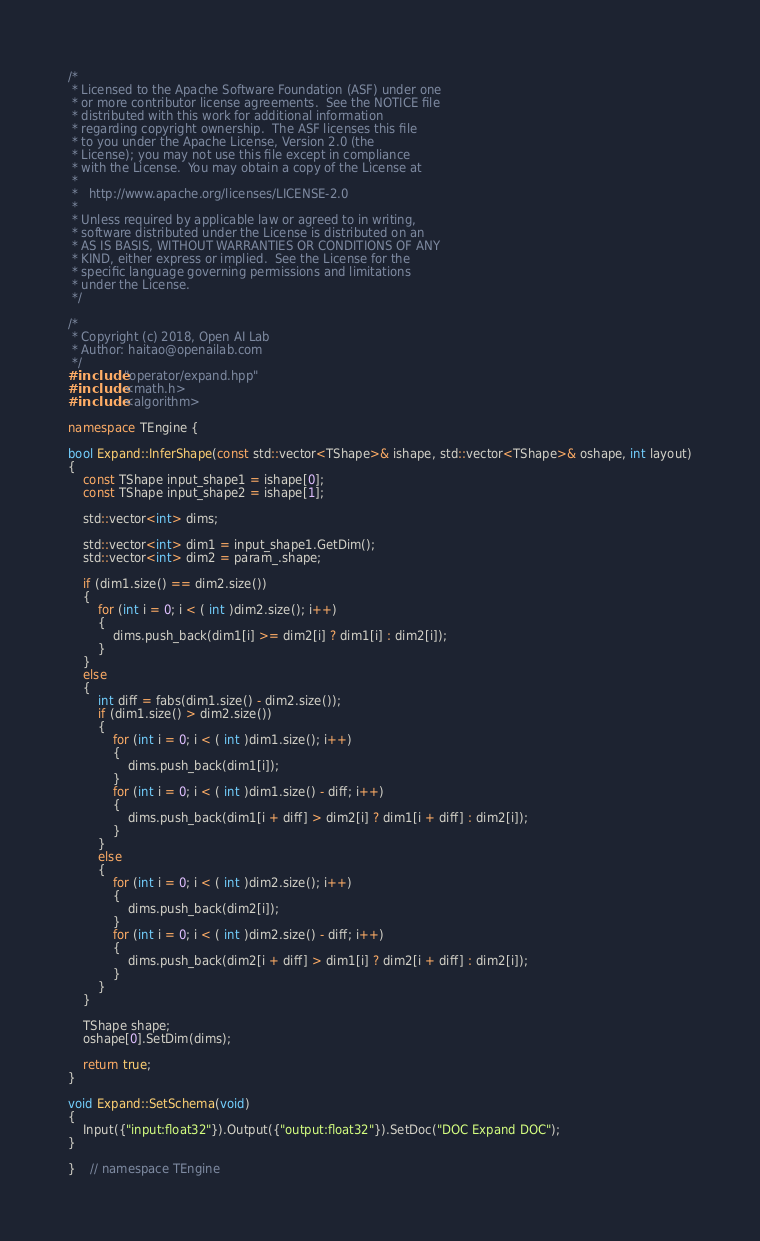Convert code to text. <code><loc_0><loc_0><loc_500><loc_500><_C++_>/*
 * Licensed to the Apache Software Foundation (ASF) under one
 * or more contributor license agreements.  See the NOTICE file
 * distributed with this work for additional information
 * regarding copyright ownership.  The ASF licenses this file
 * to you under the Apache License, Version 2.0 (the
 * License); you may not use this file except in compliance
 * with the License.  You may obtain a copy of the License at
 *
 *   http://www.apache.org/licenses/LICENSE-2.0
 *
 * Unless required by applicable law or agreed to in writing,
 * software distributed under the License is distributed on an
 * AS IS BASIS, WITHOUT WARRANTIES OR CONDITIONS OF ANY
 * KIND, either express or implied.  See the License for the
 * specific language governing permissions and limitations
 * under the License.
 */

/*
 * Copyright (c) 2018, Open AI Lab
 * Author: haitao@openailab.com
 */
#include "operator/expand.hpp"
#include <math.h>
#include <algorithm>

namespace TEngine {

bool Expand::InferShape(const std::vector<TShape>& ishape, std::vector<TShape>& oshape, int layout)
{
    const TShape input_shape1 = ishape[0];
    const TShape input_shape2 = ishape[1];

    std::vector<int> dims;

    std::vector<int> dim1 = input_shape1.GetDim();
    std::vector<int> dim2 = param_.shape;

    if (dim1.size() == dim2.size())
    {
        for (int i = 0; i < ( int )dim2.size(); i++)
        {
            dims.push_back(dim1[i] >= dim2[i] ? dim1[i] : dim2[i]);
        }
    }
    else
    {
        int diff = fabs(dim1.size() - dim2.size());
        if (dim1.size() > dim2.size())
        {
            for (int i = 0; i < ( int )dim1.size(); i++)
            {
                dims.push_back(dim1[i]);
            }
            for (int i = 0; i < ( int )dim1.size() - diff; i++)
            {
                dims.push_back(dim1[i + diff] > dim2[i] ? dim1[i + diff] : dim2[i]);
            }
        }
        else
        {
            for (int i = 0; i < ( int )dim2.size(); i++)
            {
                dims.push_back(dim2[i]);
            }
            for (int i = 0; i < ( int )dim2.size() - diff; i++)
            {
                dims.push_back(dim2[i + diff] > dim1[i] ? dim2[i + diff] : dim2[i]);
            }
        }
    }

    TShape shape;
    oshape[0].SetDim(dims);

    return true;
}

void Expand::SetSchema(void)
{
    Input({"input:float32"}).Output({"output:float32"}).SetDoc("DOC Expand DOC");
}

}    // namespace TEngine
</code> 